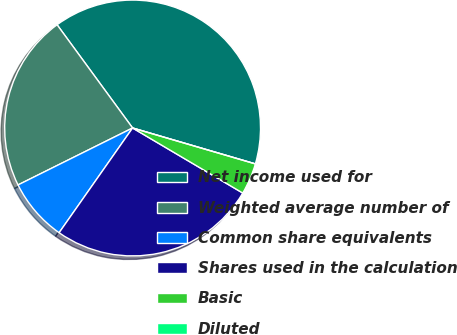Convert chart. <chart><loc_0><loc_0><loc_500><loc_500><pie_chart><fcel>Net income used for<fcel>Weighted average number of<fcel>Common share equivalents<fcel>Shares used in the calculation<fcel>Basic<fcel>Diluted<nl><fcel>39.58%<fcel>22.29%<fcel>7.92%<fcel>26.25%<fcel>3.96%<fcel>0.0%<nl></chart> 